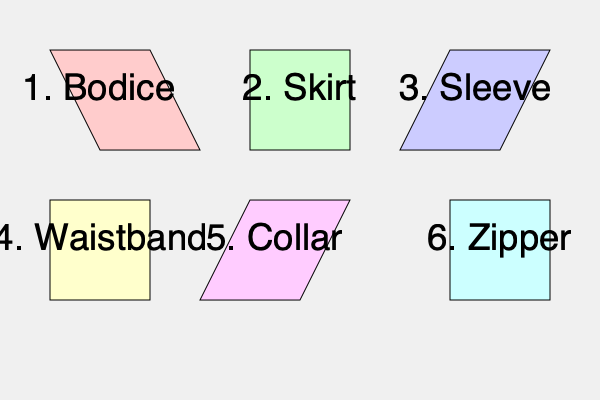Based on the 2D pattern pieces shown, what is the correct sequence for assembling a custom-made gown for Kathleen Robertson? To assemble a custom-made gown for Kathleen Robertson using the given 2D pattern pieces, follow these steps:

1. Start with the bodice (piece 1), as it forms the foundation of the gown's upper part.
2. Attach the sleeves (piece 3) to the bodice. This step is done early to ensure proper fit and movement.
3. Create the skirt (piece 2), which will form the lower part of the gown.
4. Join the bodice and skirt using the waistband (piece 4). This step connects the upper and lower parts of the gown.
5. Add the collar (piece 5) to the neckline of the bodice. This is typically done after the main structure is in place.
6. Finally, install the zipper (piece 6) to allow the gown to be put on and taken off easily.

This sequence ensures a logical progression from the core structure to the finishing details, allowing for proper fitting and adjustments throughout the process.
Answer: 1-3-2-4-5-6 